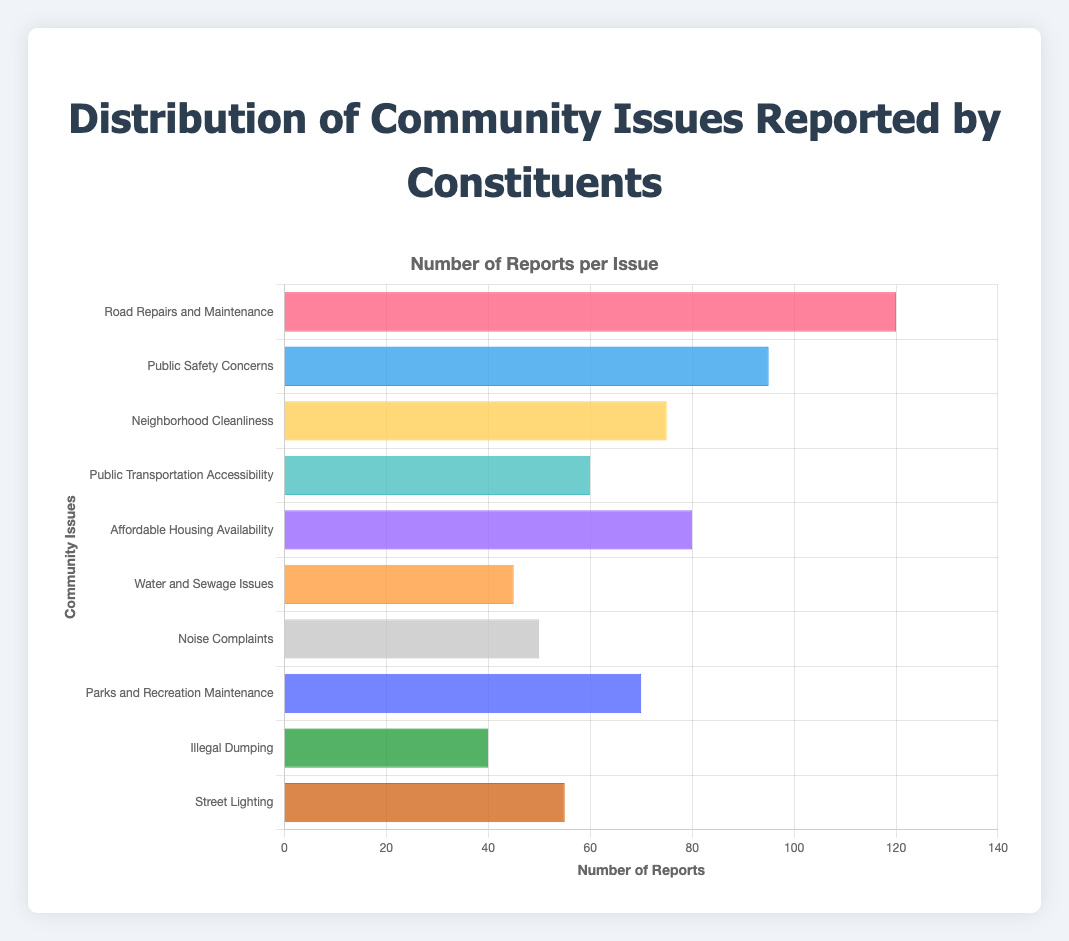What is the most frequently reported community issue? The most frequently reported community issue is the one with the highest bar length. "Road Repairs and Maintenance" has the highest number of reports at 120.
Answer: Road Repairs and Maintenance Which issue has fewer reports: Noise Complaints or Water and Sewage Issues? Compare the lengths of the bars for "Noise Complaints" and "Water and Sewage Issues". "Water and Sewage Issues" has 45 reports, while "Noise Complaints" has 50.
Answer: Water and Sewage Issues What is the total number of reports for Neighborhood Cleanliness, Affordable Housing Availability, and Parks and Recreation Maintenance combined? Add the number of reports for the three issues: 75 (Neighborhood Cleanliness) + 80 (Affordable Housing Availability) + 70 (Parks and Recreation Maintenance).
Answer: 225 Which community issue has the shortest bar (least number of reports)? Identify the bar with the shortest length. "Illegal Dumping" has the shortest bar with 40 reports.
Answer: Illegal Dumping By how much does the number of reports for "Public Safety Concerns" exceed "Street Lighting"? Subtract the number of reports for "Street Lighting" from those for "Public Safety Concerns": 95 - 55.
Answer: 40 Are there more reports for "Neighborhood Cleanliness" than "Public Transportation Accessibility"? Compare the number of reports for "Neighborhood Cleanliness" (75) with "Public Transportation Accessibility" (60).
Answer: Yes What is the combined total of reports for issues related to infrastructure (Road Repairs and Maintenance, Water and Sewage Issues, Street Lighting)? Add the number of reports for each infrastructure-related issue: 120 + 45 + 55.
Answer: 220 Which issue with a bluish color has fewer reports, "Public Safety Concerns" or "Public Transportation Accessibility"? Identify which of the bluish-colored bars has fewer reports. "Public Safety Concerns" has 95 reports, while "Public Transportation Accessibility" has 60.
Answer: Public Transportation Accessibility What is the average number of reports for all issues? Add up all the reports and divide by the number of issues: (120 + 95 + 75 + 60 + 80 + 45 + 50 + 70 + 40 + 55) / 10.
Answer: 69 Compare the range of reports by subtracting the smallest number of reports from the largest. What is the result? Calculate the range by subtracting the smallest number of reports (40 for Illegal Dumping) from the largest (120 for Road Repairs and Maintenance): 120 - 40.
Answer: 80 